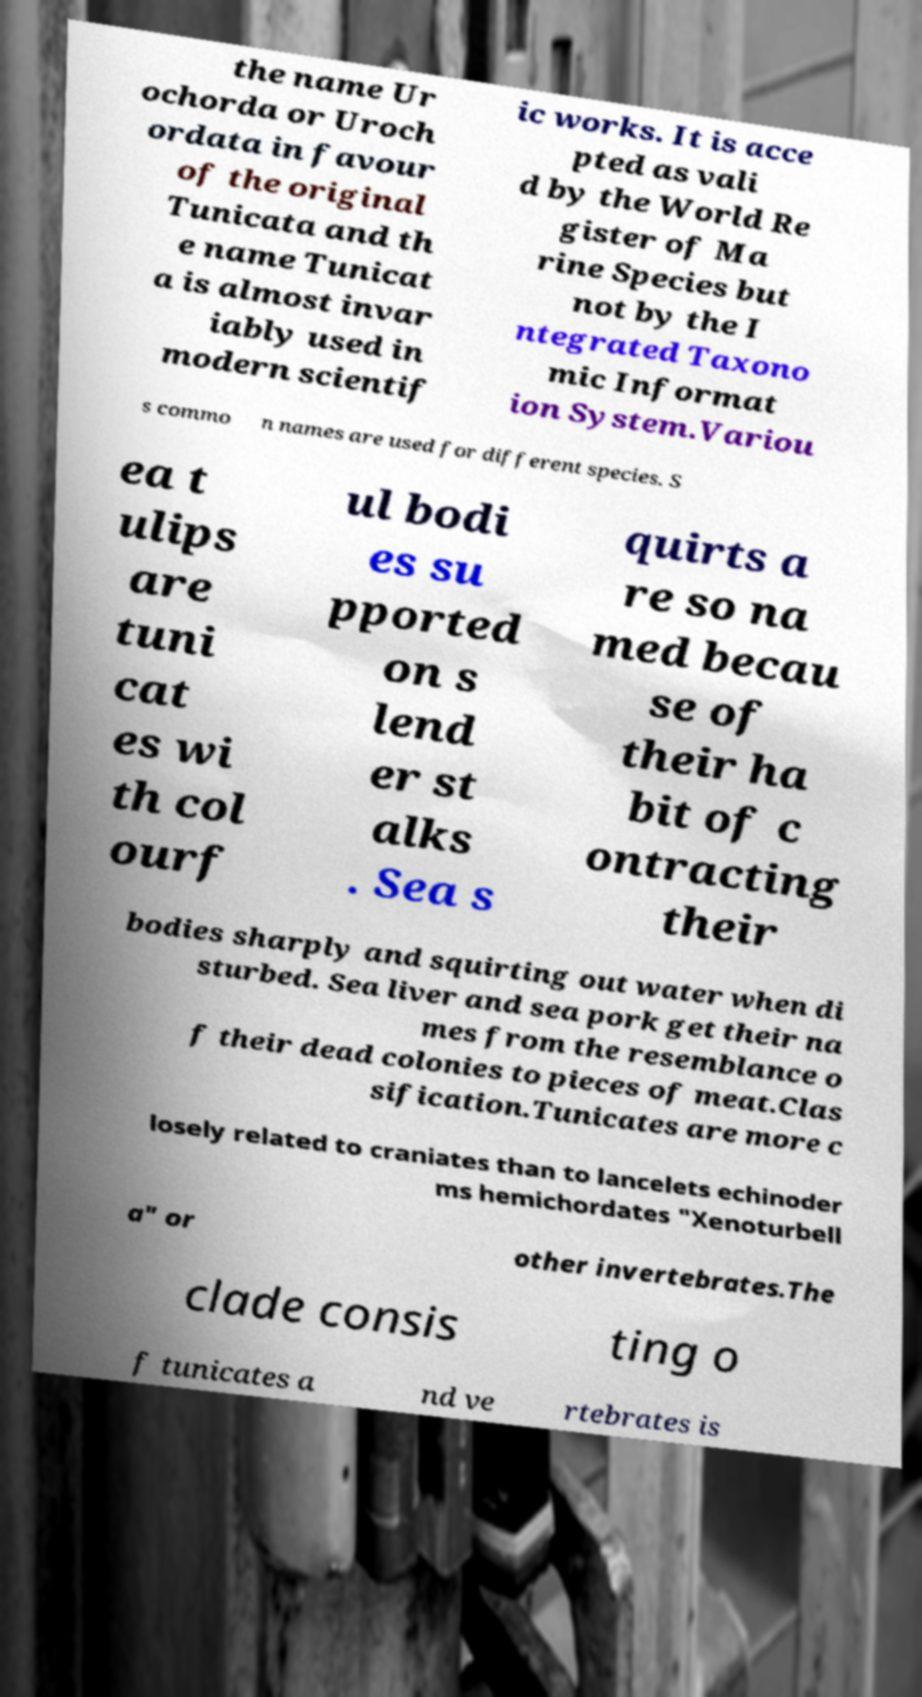Can you read and provide the text displayed in the image?This photo seems to have some interesting text. Can you extract and type it out for me? the name Ur ochorda or Uroch ordata in favour of the original Tunicata and th e name Tunicat a is almost invar iably used in modern scientif ic works. It is acce pted as vali d by the World Re gister of Ma rine Species but not by the I ntegrated Taxono mic Informat ion System.Variou s commo n names are used for different species. S ea t ulips are tuni cat es wi th col ourf ul bodi es su pported on s lend er st alks . Sea s quirts a re so na med becau se of their ha bit of c ontracting their bodies sharply and squirting out water when di sturbed. Sea liver and sea pork get their na mes from the resemblance o f their dead colonies to pieces of meat.Clas sification.Tunicates are more c losely related to craniates than to lancelets echinoder ms hemichordates "Xenoturbell a" or other invertebrates.The clade consis ting o f tunicates a nd ve rtebrates is 